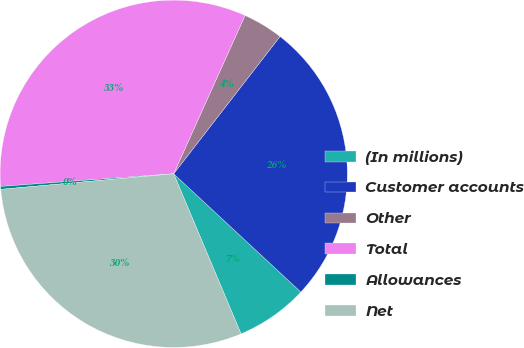Convert chart to OTSL. <chart><loc_0><loc_0><loc_500><loc_500><pie_chart><fcel>(In millions)<fcel>Customer accounts<fcel>Other<fcel>Total<fcel>Allowances<fcel>Net<nl><fcel>6.74%<fcel>26.43%<fcel>3.75%<fcel>32.9%<fcel>0.27%<fcel>29.91%<nl></chart> 